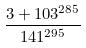Convert formula to latex. <formula><loc_0><loc_0><loc_500><loc_500>\frac { 3 + 1 0 3 ^ { 2 8 5 } } { 1 4 1 ^ { 2 9 5 } }</formula> 